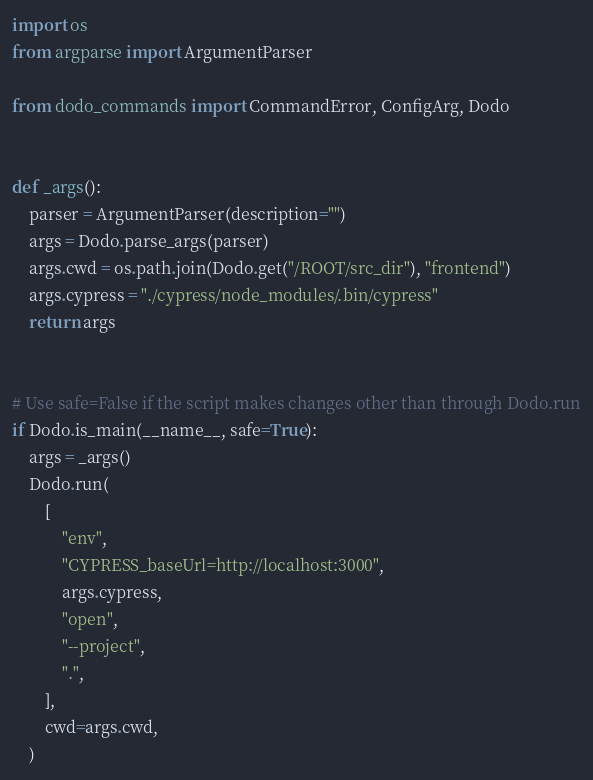Convert code to text. <code><loc_0><loc_0><loc_500><loc_500><_Python_>import os
from argparse import ArgumentParser

from dodo_commands import CommandError, ConfigArg, Dodo


def _args():
    parser = ArgumentParser(description="")
    args = Dodo.parse_args(parser)
    args.cwd = os.path.join(Dodo.get("/ROOT/src_dir"), "frontend")
    args.cypress = "./cypress/node_modules/.bin/cypress"
    return args


# Use safe=False if the script makes changes other than through Dodo.run
if Dodo.is_main(__name__, safe=True):
    args = _args()
    Dodo.run(
        [
            "env",
            "CYPRESS_baseUrl=http://localhost:3000",
            args.cypress,
            "open",
            "--project",
            ".",
        ],
        cwd=args.cwd,
    )
</code> 